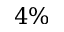Convert formula to latex. <formula><loc_0><loc_0><loc_500><loc_500>4 \%</formula> 